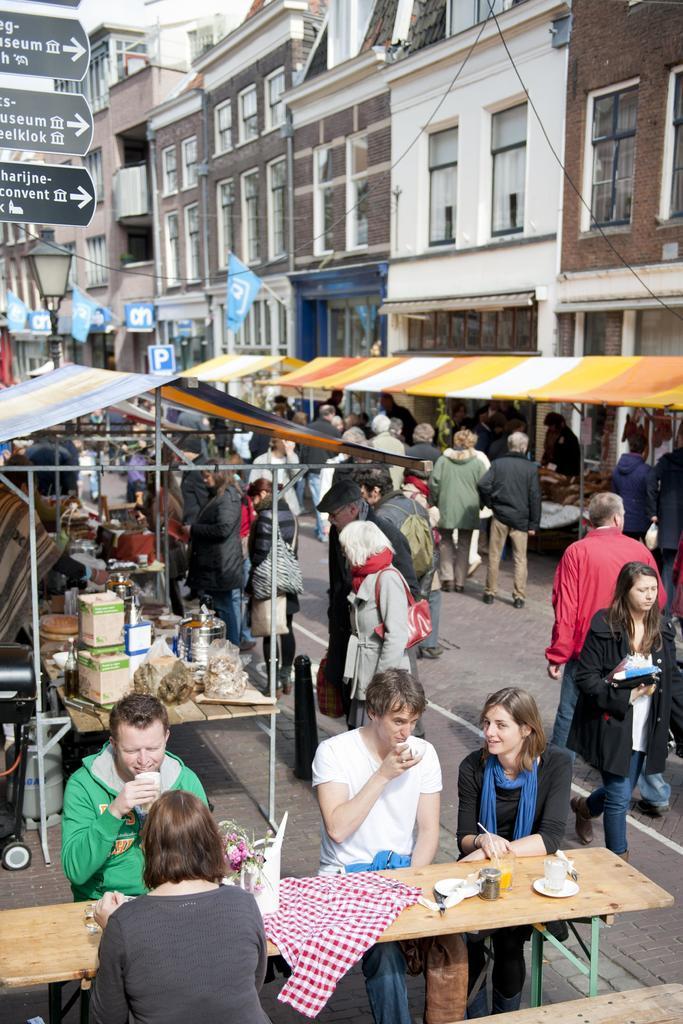Can you describe this image briefly? This picture shows few buildings and Few stores on the sidewalk Few people standing and few people seated on the chairs. 